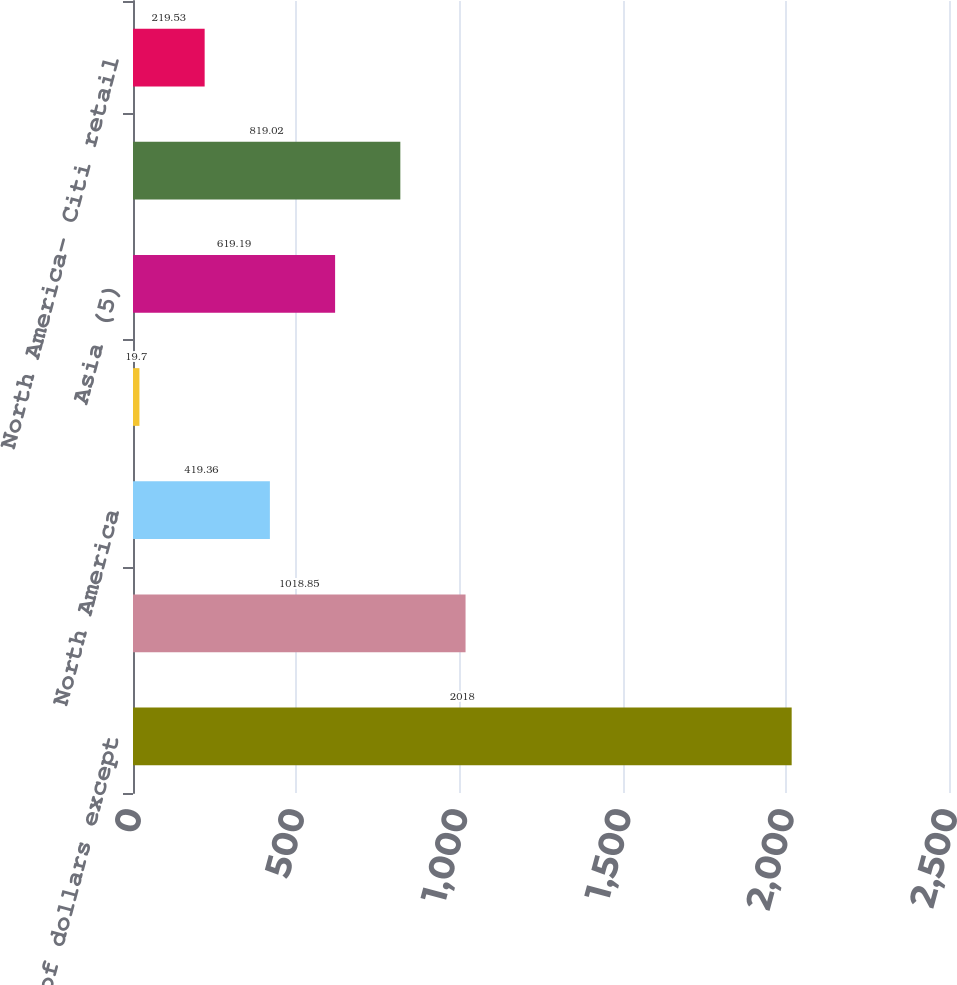Convert chart. <chart><loc_0><loc_0><loc_500><loc_500><bar_chart><fcel>In millions of dollars except<fcel>Total<fcel>North America<fcel>Latin America<fcel>Asia (5)<fcel>North America- Citi-branded<fcel>North America- Citi retail<nl><fcel>2018<fcel>1018.85<fcel>419.36<fcel>19.7<fcel>619.19<fcel>819.02<fcel>219.53<nl></chart> 